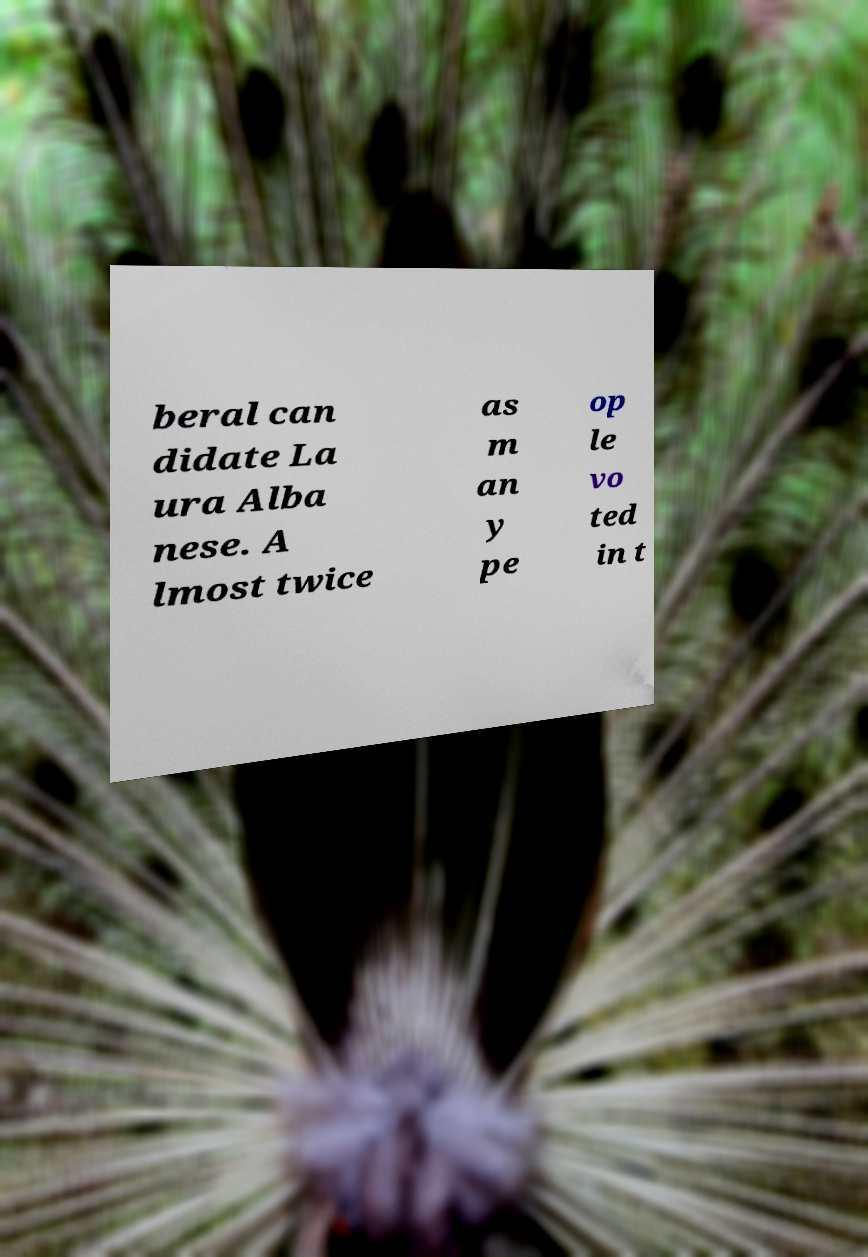What messages or text are displayed in this image? I need them in a readable, typed format. beral can didate La ura Alba nese. A lmost twice as m an y pe op le vo ted in t 